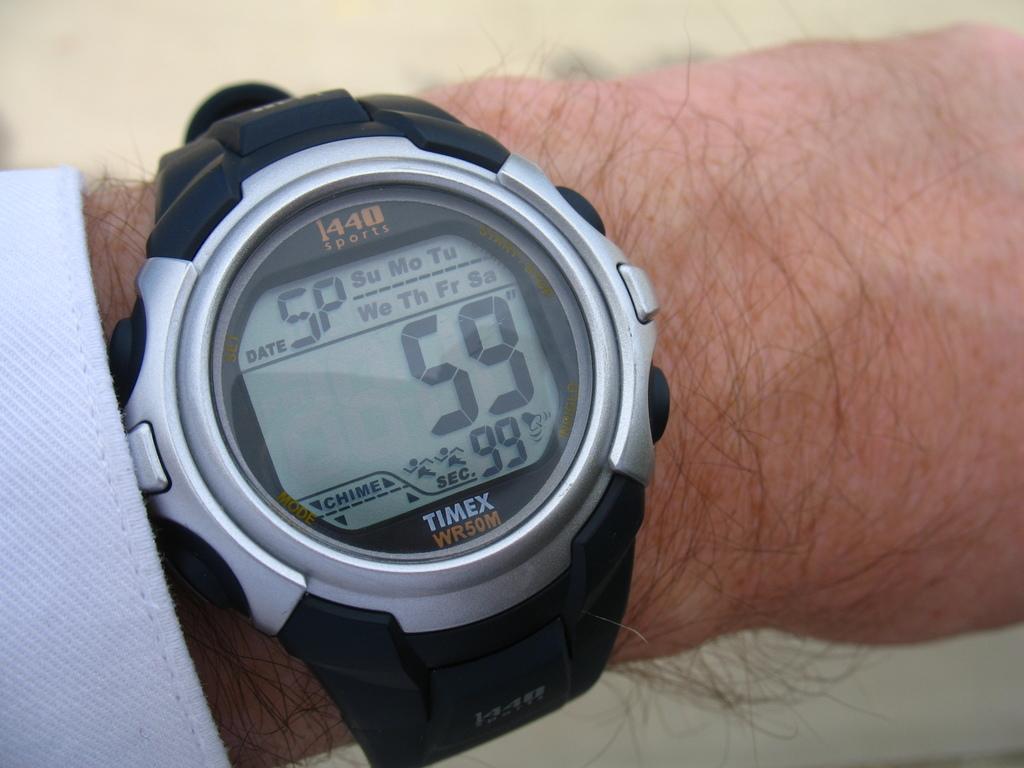What is the make and model of this watch?
Offer a very short reply. Timex wr50m. What number is shown large in the middle?
Offer a very short reply. 59. 